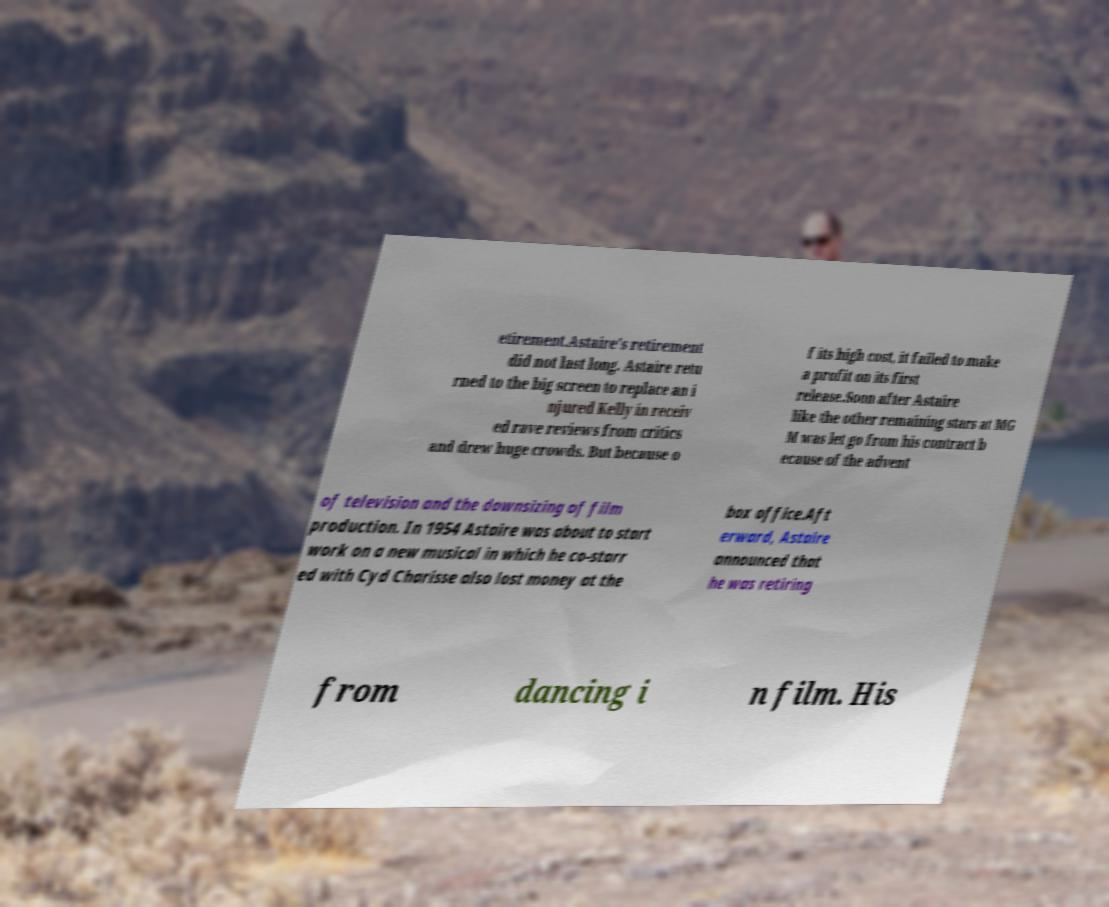Could you extract and type out the text from this image? etirement.Astaire's retirement did not last long. Astaire retu rned to the big screen to replace an i njured Kelly in receiv ed rave reviews from critics and drew huge crowds. But because o f its high cost, it failed to make a profit on its first release.Soon after Astaire like the other remaining stars at MG M was let go from his contract b ecause of the advent of television and the downsizing of film production. In 1954 Astaire was about to start work on a new musical in which he co-starr ed with Cyd Charisse also lost money at the box office.Aft erward, Astaire announced that he was retiring from dancing i n film. His 